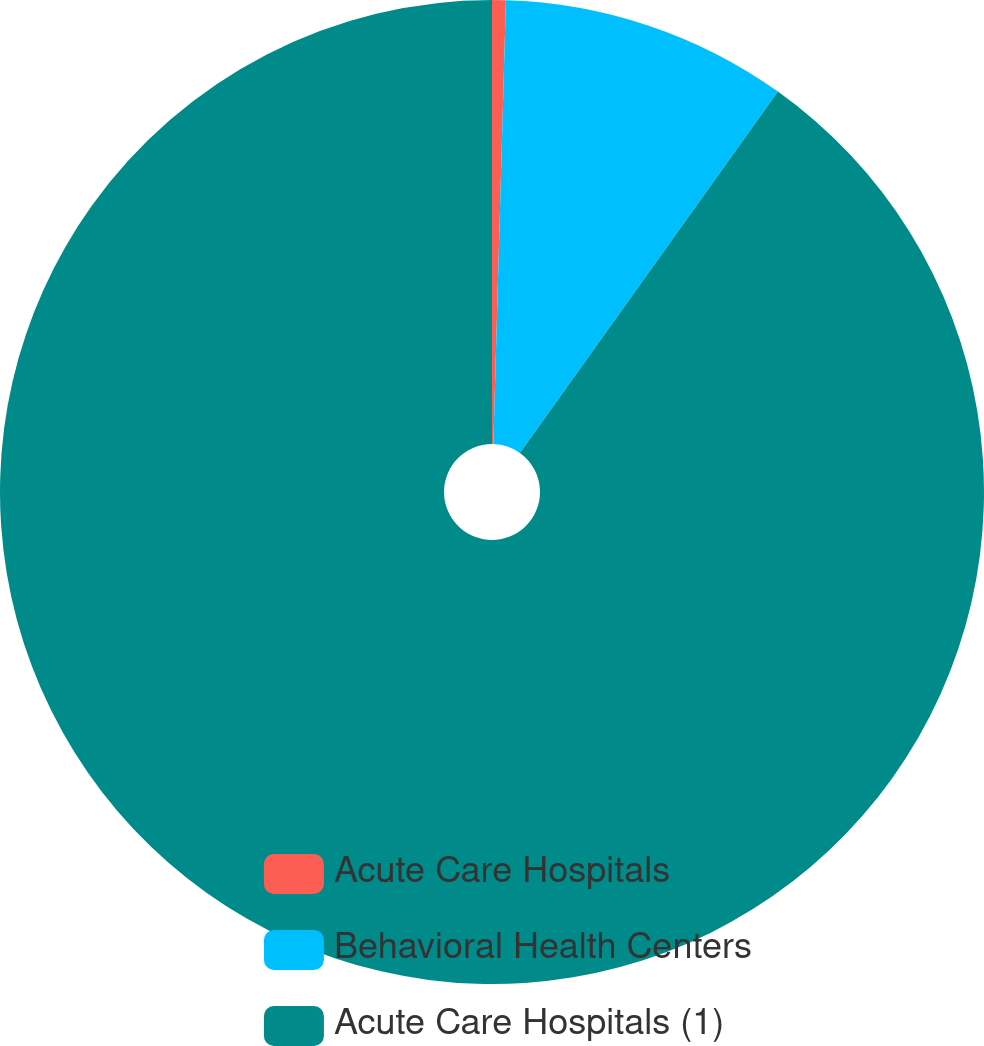Convert chart to OTSL. <chart><loc_0><loc_0><loc_500><loc_500><pie_chart><fcel>Acute Care Hospitals<fcel>Behavioral Health Centers<fcel>Acute Care Hospitals (1)<nl><fcel>0.45%<fcel>9.42%<fcel>90.14%<nl></chart> 